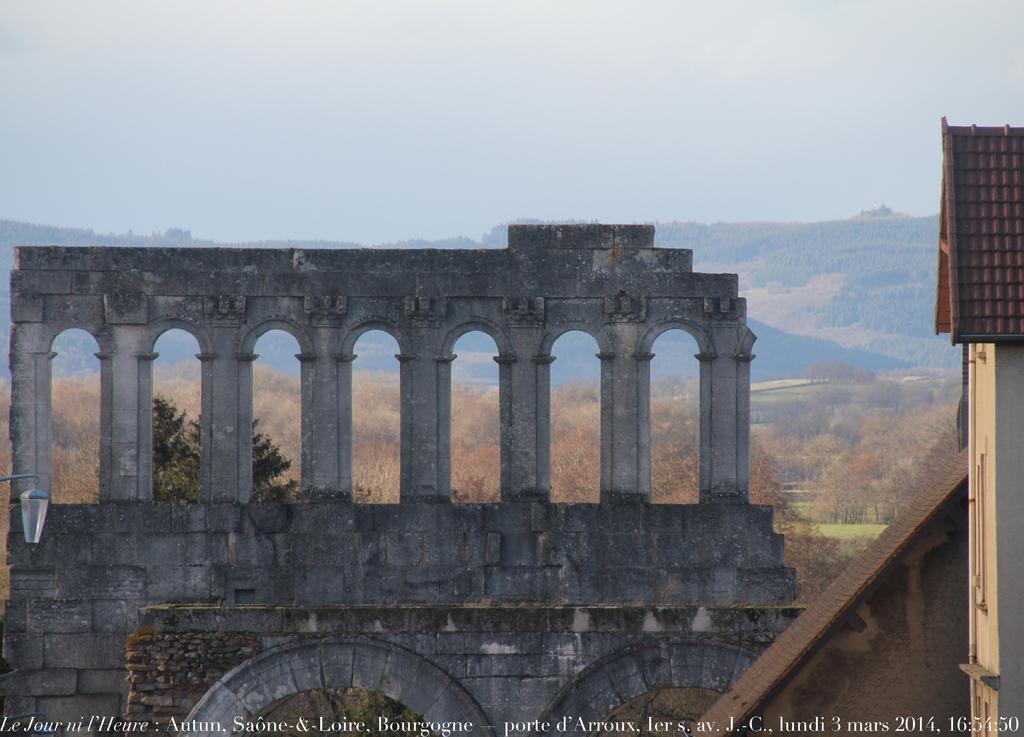How would you summarize this image in a sentence or two? In this image we can see sky, hills, monument, trees and ground. 